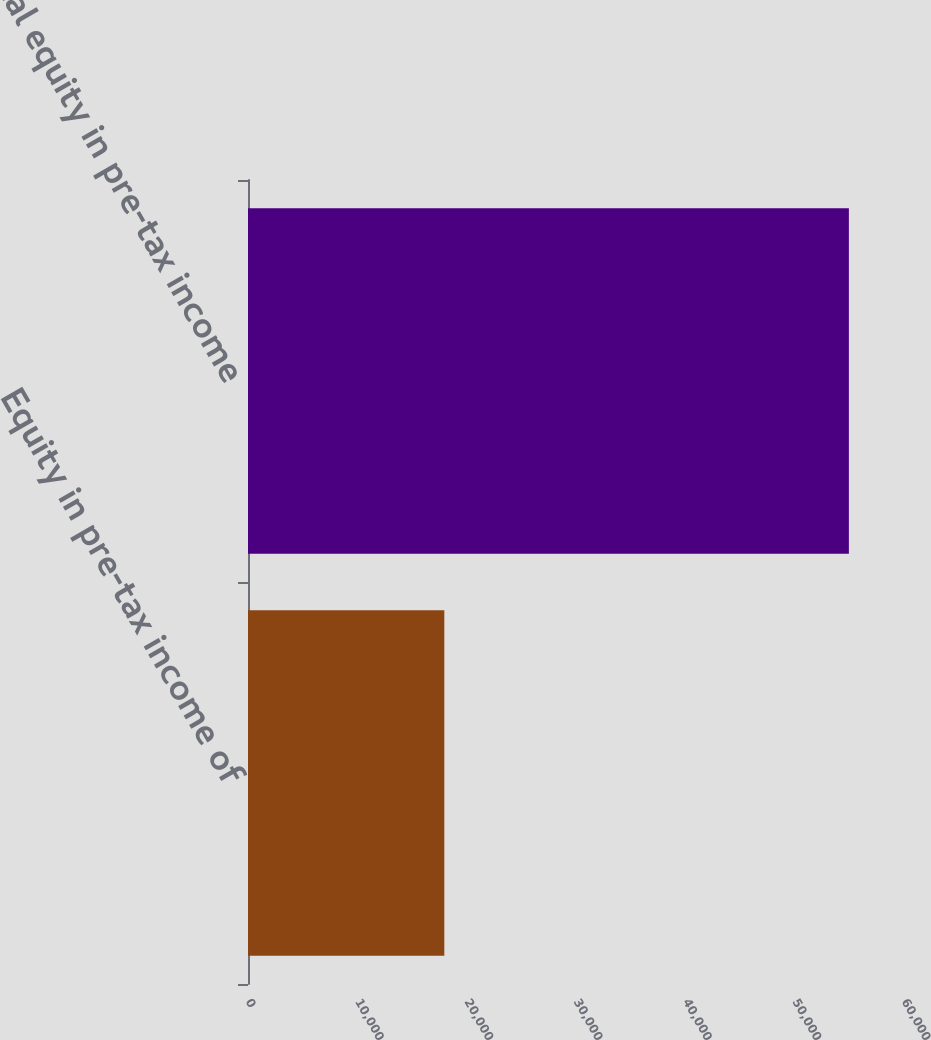<chart> <loc_0><loc_0><loc_500><loc_500><bar_chart><fcel>Equity in pre-tax income of<fcel>Total equity in pre-tax income<nl><fcel>17956<fcel>54958<nl></chart> 